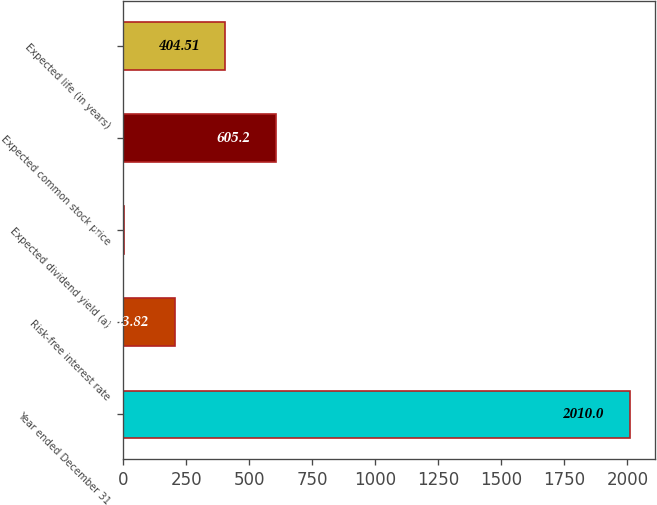<chart> <loc_0><loc_0><loc_500><loc_500><bar_chart><fcel>Year ended December 31<fcel>Risk-free interest rate<fcel>Expected dividend yield (a)<fcel>Expected common stock price<fcel>Expected life (in years)<nl><fcel>2010<fcel>203.82<fcel>3.13<fcel>605.2<fcel>404.51<nl></chart> 